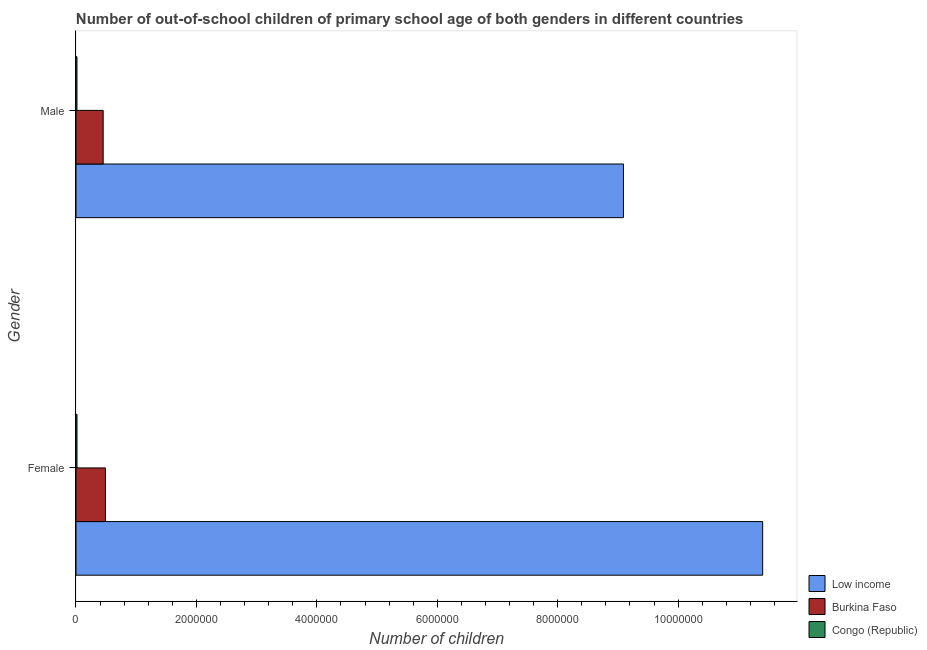How many groups of bars are there?
Provide a succinct answer. 2. How many bars are there on the 2nd tick from the top?
Your answer should be very brief. 3. What is the number of male out-of-school students in Low income?
Your answer should be compact. 9.09e+06. Across all countries, what is the maximum number of female out-of-school students?
Your response must be concise. 1.14e+07. Across all countries, what is the minimum number of male out-of-school students?
Your answer should be compact. 1.60e+04. In which country was the number of male out-of-school students minimum?
Make the answer very short. Congo (Republic). What is the total number of male out-of-school students in the graph?
Make the answer very short. 9.56e+06. What is the difference between the number of male out-of-school students in Low income and that in Congo (Republic)?
Keep it short and to the point. 9.08e+06. What is the difference between the number of male out-of-school students in Burkina Faso and the number of female out-of-school students in Low income?
Provide a succinct answer. -1.10e+07. What is the average number of male out-of-school students per country?
Your answer should be compact. 3.19e+06. What is the difference between the number of female out-of-school students and number of male out-of-school students in Congo (Republic)?
Offer a very short reply. 818. In how many countries, is the number of male out-of-school students greater than 2000000 ?
Give a very brief answer. 1. What is the ratio of the number of female out-of-school students in Low income to that in Congo (Republic)?
Keep it short and to the point. 679.69. Is the number of female out-of-school students in Low income less than that in Congo (Republic)?
Keep it short and to the point. No. What does the 1st bar from the top in Male represents?
Give a very brief answer. Congo (Republic). What does the 3rd bar from the bottom in Male represents?
Give a very brief answer. Congo (Republic). How many bars are there?
Make the answer very short. 6. What is the difference between two consecutive major ticks on the X-axis?
Keep it short and to the point. 2.00e+06. Are the values on the major ticks of X-axis written in scientific E-notation?
Your answer should be very brief. No. Does the graph contain any zero values?
Your answer should be very brief. No. How are the legend labels stacked?
Offer a very short reply. Vertical. What is the title of the graph?
Provide a short and direct response. Number of out-of-school children of primary school age of both genders in different countries. Does "East Asia (all income levels)" appear as one of the legend labels in the graph?
Your response must be concise. No. What is the label or title of the X-axis?
Offer a terse response. Number of children. What is the Number of children in Low income in Female?
Make the answer very short. 1.14e+07. What is the Number of children of Burkina Faso in Female?
Your answer should be very brief. 4.89e+05. What is the Number of children of Congo (Republic) in Female?
Make the answer very short. 1.68e+04. What is the Number of children in Low income in Male?
Make the answer very short. 9.09e+06. What is the Number of children in Burkina Faso in Male?
Offer a very short reply. 4.51e+05. What is the Number of children in Congo (Republic) in Male?
Your answer should be compact. 1.60e+04. Across all Gender, what is the maximum Number of children in Low income?
Provide a succinct answer. 1.14e+07. Across all Gender, what is the maximum Number of children of Burkina Faso?
Make the answer very short. 4.89e+05. Across all Gender, what is the maximum Number of children in Congo (Republic)?
Your answer should be compact. 1.68e+04. Across all Gender, what is the minimum Number of children in Low income?
Keep it short and to the point. 9.09e+06. Across all Gender, what is the minimum Number of children of Burkina Faso?
Ensure brevity in your answer.  4.51e+05. Across all Gender, what is the minimum Number of children of Congo (Republic)?
Provide a succinct answer. 1.60e+04. What is the total Number of children of Low income in the graph?
Provide a succinct answer. 2.05e+07. What is the total Number of children in Burkina Faso in the graph?
Provide a short and direct response. 9.40e+05. What is the total Number of children in Congo (Republic) in the graph?
Offer a terse response. 3.27e+04. What is the difference between the Number of children in Low income in Female and that in Male?
Provide a succinct answer. 2.31e+06. What is the difference between the Number of children of Burkina Faso in Female and that in Male?
Your answer should be compact. 3.72e+04. What is the difference between the Number of children of Congo (Republic) in Female and that in Male?
Offer a very short reply. 818. What is the difference between the Number of children of Low income in Female and the Number of children of Burkina Faso in Male?
Ensure brevity in your answer.  1.10e+07. What is the difference between the Number of children of Low income in Female and the Number of children of Congo (Republic) in Male?
Offer a very short reply. 1.14e+07. What is the difference between the Number of children in Burkina Faso in Female and the Number of children in Congo (Republic) in Male?
Offer a terse response. 4.73e+05. What is the average Number of children in Low income per Gender?
Your answer should be compact. 1.02e+07. What is the average Number of children of Burkina Faso per Gender?
Provide a succinct answer. 4.70e+05. What is the average Number of children of Congo (Republic) per Gender?
Offer a very short reply. 1.64e+04. What is the difference between the Number of children in Low income and Number of children in Burkina Faso in Female?
Offer a very short reply. 1.09e+07. What is the difference between the Number of children of Low income and Number of children of Congo (Republic) in Female?
Offer a terse response. 1.14e+07. What is the difference between the Number of children in Burkina Faso and Number of children in Congo (Republic) in Female?
Your answer should be compact. 4.72e+05. What is the difference between the Number of children in Low income and Number of children in Burkina Faso in Male?
Provide a short and direct response. 8.64e+06. What is the difference between the Number of children in Low income and Number of children in Congo (Republic) in Male?
Ensure brevity in your answer.  9.08e+06. What is the difference between the Number of children of Burkina Faso and Number of children of Congo (Republic) in Male?
Your answer should be very brief. 4.36e+05. What is the ratio of the Number of children of Low income in Female to that in Male?
Offer a terse response. 1.25. What is the ratio of the Number of children of Burkina Faso in Female to that in Male?
Make the answer very short. 1.08. What is the ratio of the Number of children of Congo (Republic) in Female to that in Male?
Keep it short and to the point. 1.05. What is the difference between the highest and the second highest Number of children in Low income?
Your response must be concise. 2.31e+06. What is the difference between the highest and the second highest Number of children in Burkina Faso?
Make the answer very short. 3.72e+04. What is the difference between the highest and the second highest Number of children of Congo (Republic)?
Give a very brief answer. 818. What is the difference between the highest and the lowest Number of children of Low income?
Provide a short and direct response. 2.31e+06. What is the difference between the highest and the lowest Number of children of Burkina Faso?
Offer a terse response. 3.72e+04. What is the difference between the highest and the lowest Number of children in Congo (Republic)?
Offer a terse response. 818. 